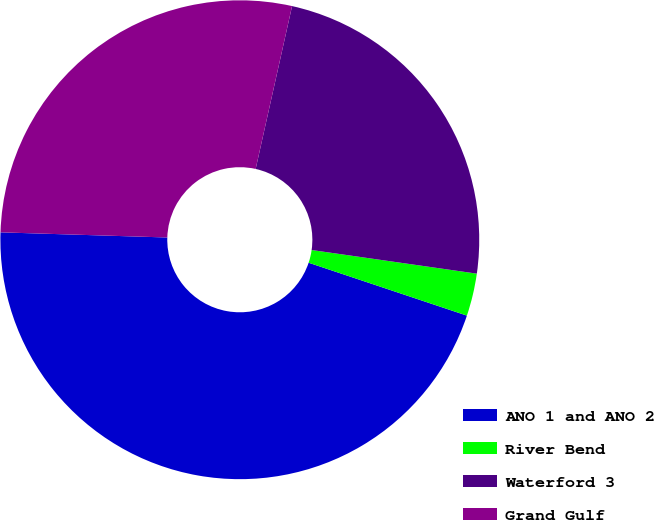Convert chart to OTSL. <chart><loc_0><loc_0><loc_500><loc_500><pie_chart><fcel>ANO 1 and ANO 2<fcel>River Bend<fcel>Waterford 3<fcel>Grand Gulf<nl><fcel>45.36%<fcel>2.87%<fcel>23.76%<fcel>28.01%<nl></chart> 